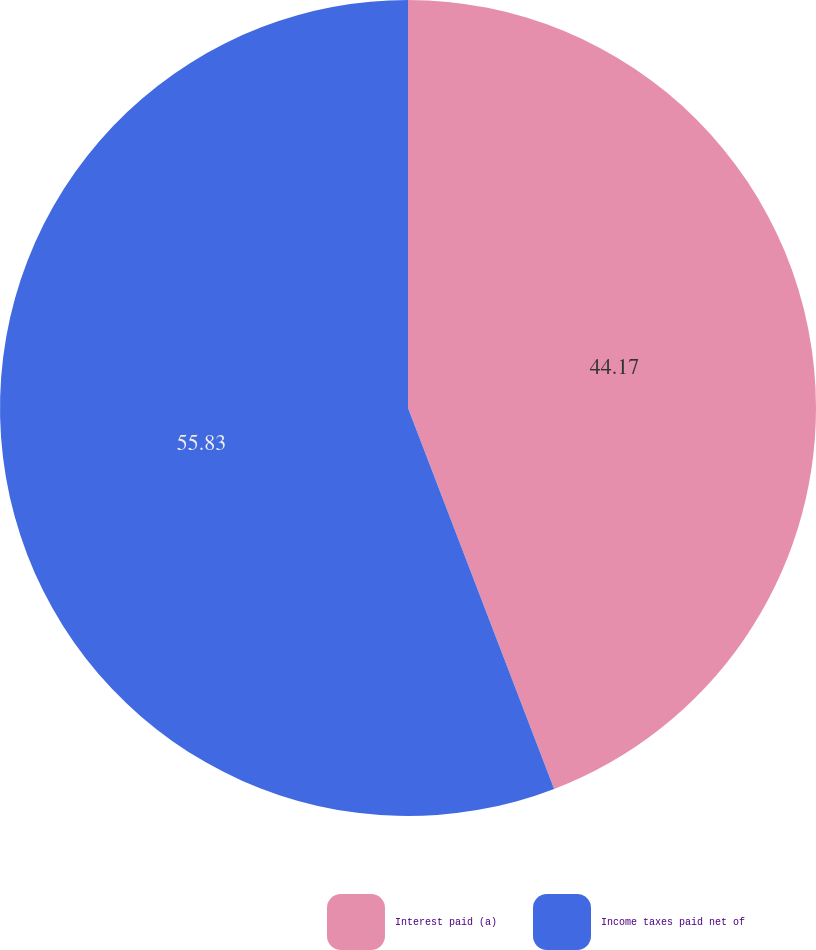<chart> <loc_0><loc_0><loc_500><loc_500><pie_chart><fcel>Interest paid (a)<fcel>Income taxes paid net of<nl><fcel>44.17%<fcel>55.83%<nl></chart> 